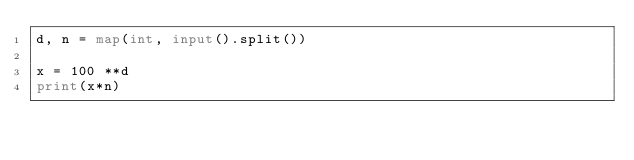<code> <loc_0><loc_0><loc_500><loc_500><_Python_>d, n = map(int, input().split())

x = 100 **d
print(x*n)</code> 